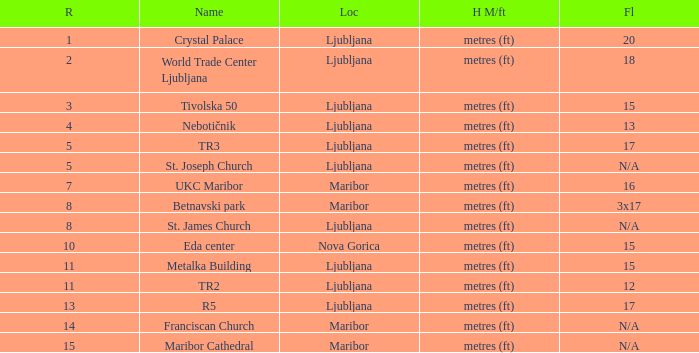Which Rank is the lowest one that has a Name of maribor cathedral? 15.0. 